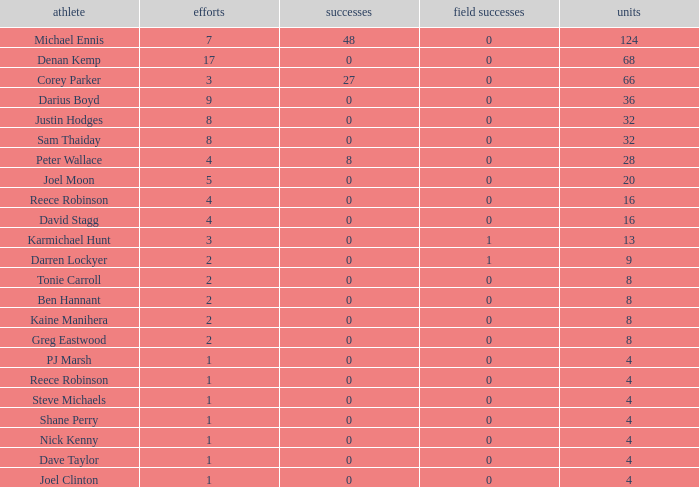What is the lowest tries the player with more than 0 goals, 28 points, and more than 0 field goals have? None. Would you be able to parse every entry in this table? {'header': ['athlete', 'efforts', 'successes', 'field successes', 'units'], 'rows': [['Michael Ennis', '7', '48', '0', '124'], ['Denan Kemp', '17', '0', '0', '68'], ['Corey Parker', '3', '27', '0', '66'], ['Darius Boyd', '9', '0', '0', '36'], ['Justin Hodges', '8', '0', '0', '32'], ['Sam Thaiday', '8', '0', '0', '32'], ['Peter Wallace', '4', '8', '0', '28'], ['Joel Moon', '5', '0', '0', '20'], ['Reece Robinson', '4', '0', '0', '16'], ['David Stagg', '4', '0', '0', '16'], ['Karmichael Hunt', '3', '0', '1', '13'], ['Darren Lockyer', '2', '0', '1', '9'], ['Tonie Carroll', '2', '0', '0', '8'], ['Ben Hannant', '2', '0', '0', '8'], ['Kaine Manihera', '2', '0', '0', '8'], ['Greg Eastwood', '2', '0', '0', '8'], ['PJ Marsh', '1', '0', '0', '4'], ['Reece Robinson', '1', '0', '0', '4'], ['Steve Michaels', '1', '0', '0', '4'], ['Shane Perry', '1', '0', '0', '4'], ['Nick Kenny', '1', '0', '0', '4'], ['Dave Taylor', '1', '0', '0', '4'], ['Joel Clinton', '1', '0', '0', '4']]} 